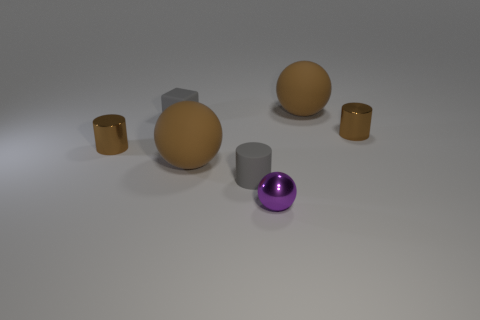Subtract all tiny metal balls. How many balls are left? 2 Subtract all blue spheres. How many brown cylinders are left? 2 Add 3 tiny gray matte cylinders. How many objects exist? 10 Subtract 1 cylinders. How many cylinders are left? 2 Subtract all balls. How many objects are left? 4 Subtract all red balls. Subtract all gray blocks. How many balls are left? 3 Add 2 small metal objects. How many small metal objects exist? 5 Subtract 0 brown blocks. How many objects are left? 7 Subtract all yellow matte cylinders. Subtract all tiny cylinders. How many objects are left? 4 Add 2 small gray cylinders. How many small gray cylinders are left? 3 